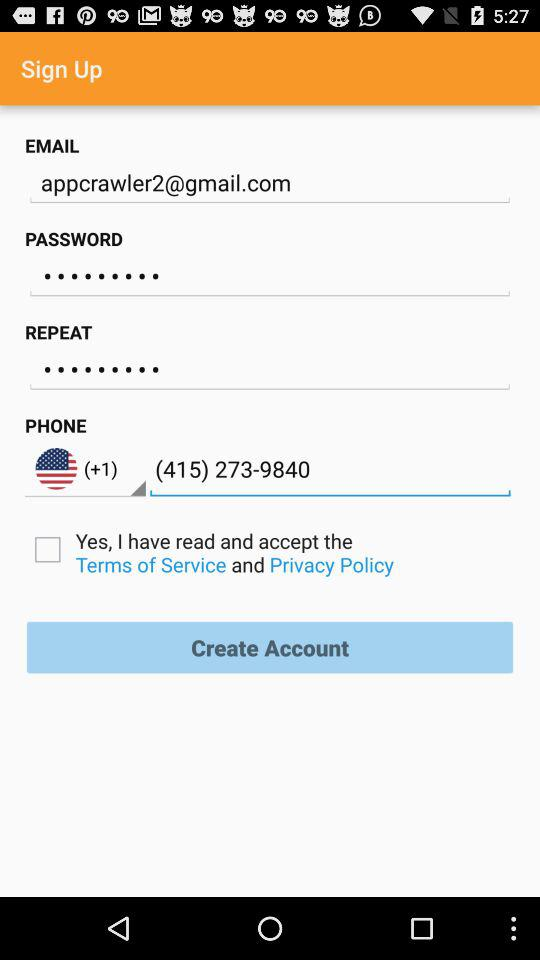What is the status of the option that includes acceptance of the “Terms of Service” and “Privacy Policy”? The status is "off". 